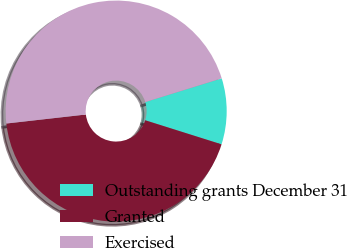Convert chart. <chart><loc_0><loc_0><loc_500><loc_500><pie_chart><fcel>Outstanding grants December 31<fcel>Granted<fcel>Exercised<nl><fcel>9.65%<fcel>43.34%<fcel>47.01%<nl></chart> 